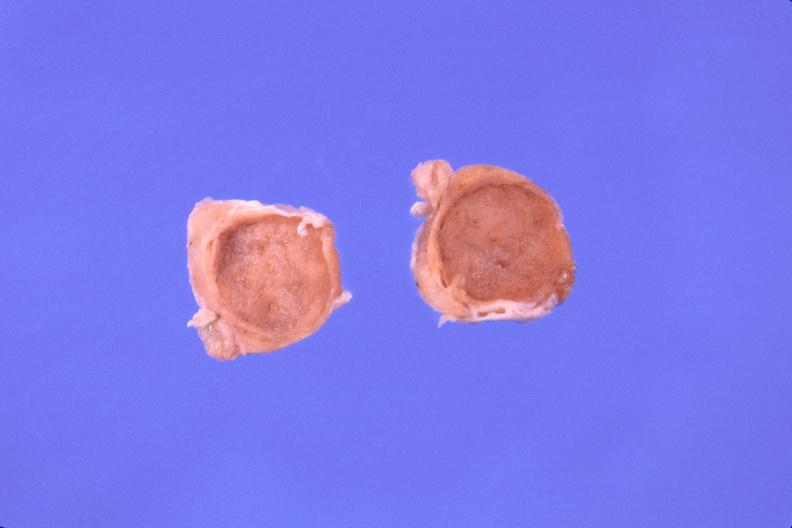where does this belong to?
Answer the question using a single word or phrase. Endocrine system 